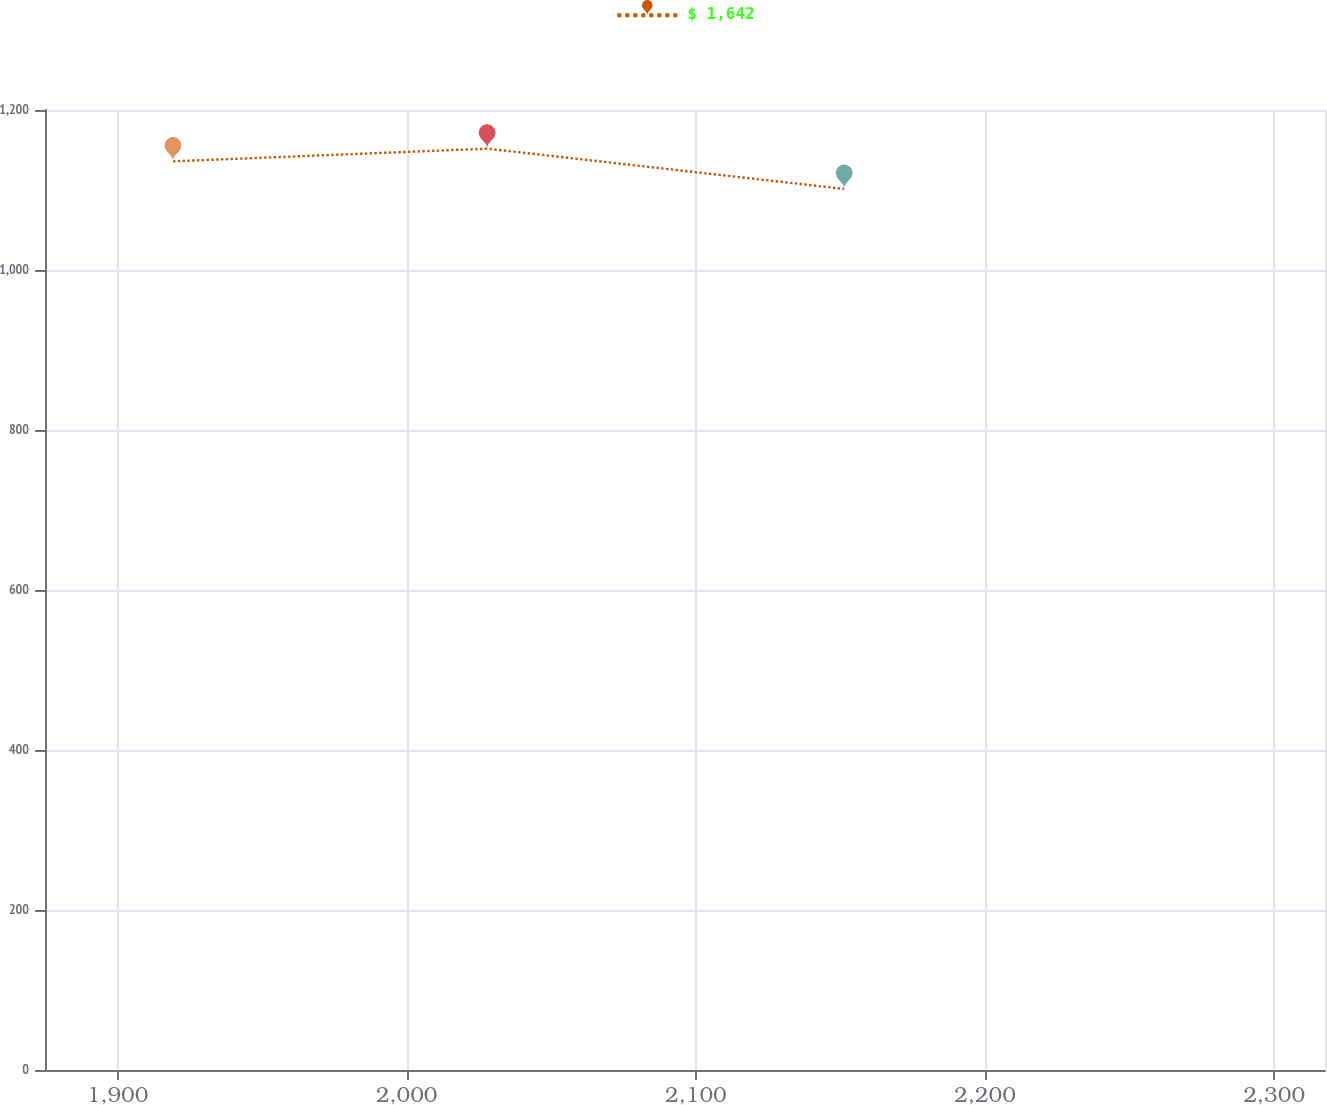Convert chart to OTSL. <chart><loc_0><loc_0><loc_500><loc_500><line_chart><ecel><fcel>$ 1,642<nl><fcel>1919.18<fcel>1135.82<nl><fcel>2027.8<fcel>1151.68<nl><fcel>2151.27<fcel>1101.3<nl><fcel>2361.82<fcel>1095.7<nl></chart> 